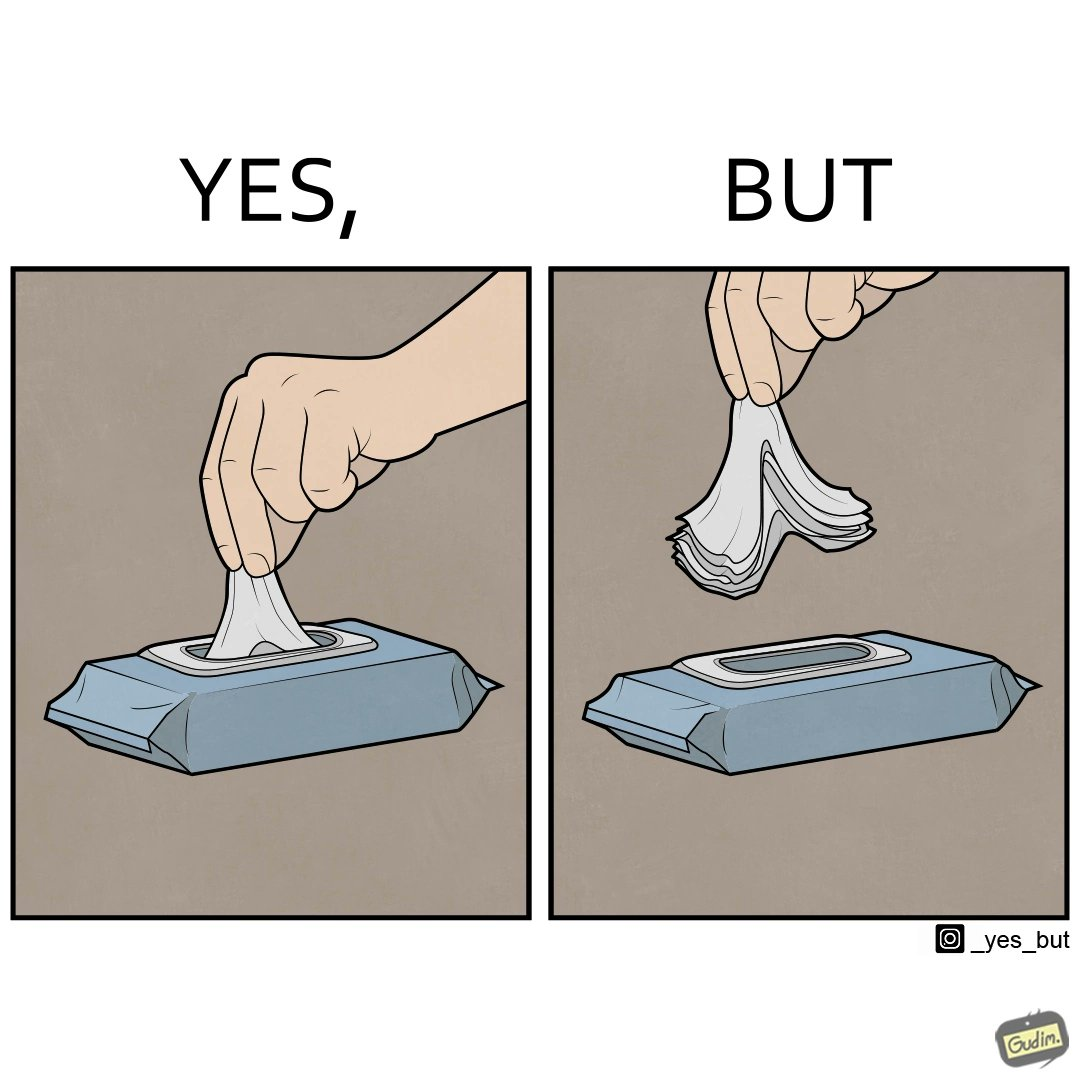What do you see in each half of this image? In the left part of the image: a person pulling out a napkin from the box In the right part of the image: a person pulling many napkin out of a box together 